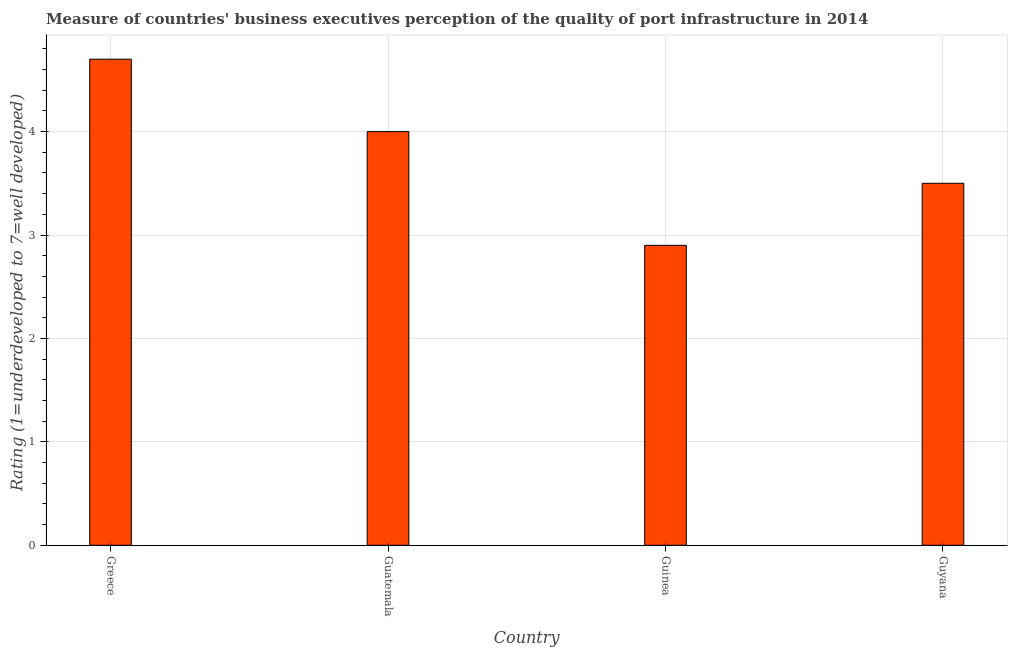Does the graph contain any zero values?
Give a very brief answer. No. What is the title of the graph?
Make the answer very short. Measure of countries' business executives perception of the quality of port infrastructure in 2014. What is the label or title of the Y-axis?
Offer a very short reply. Rating (1=underdeveloped to 7=well developed) . Across all countries, what is the maximum rating measuring quality of port infrastructure?
Offer a terse response. 4.7. In which country was the rating measuring quality of port infrastructure minimum?
Your answer should be compact. Guinea. What is the sum of the rating measuring quality of port infrastructure?
Provide a short and direct response. 15.1. What is the average rating measuring quality of port infrastructure per country?
Give a very brief answer. 3.77. What is the median rating measuring quality of port infrastructure?
Your answer should be very brief. 3.75. What is the ratio of the rating measuring quality of port infrastructure in Guatemala to that in Guyana?
Your answer should be compact. 1.14. Is the difference between the rating measuring quality of port infrastructure in Greece and Guinea greater than the difference between any two countries?
Keep it short and to the point. Yes. What is the difference between the highest and the lowest rating measuring quality of port infrastructure?
Provide a short and direct response. 1.8. How many bars are there?
Give a very brief answer. 4. Are all the bars in the graph horizontal?
Your answer should be compact. No. What is the difference between two consecutive major ticks on the Y-axis?
Keep it short and to the point. 1. Are the values on the major ticks of Y-axis written in scientific E-notation?
Make the answer very short. No. What is the Rating (1=underdeveloped to 7=well developed)  of Greece?
Your answer should be compact. 4.7. What is the Rating (1=underdeveloped to 7=well developed)  in Guatemala?
Offer a terse response. 4. What is the Rating (1=underdeveloped to 7=well developed)  in Guinea?
Provide a succinct answer. 2.9. What is the difference between the Rating (1=underdeveloped to 7=well developed)  in Greece and Guatemala?
Provide a succinct answer. 0.7. What is the difference between the Rating (1=underdeveloped to 7=well developed)  in Greece and Guinea?
Provide a succinct answer. 1.8. What is the difference between the Rating (1=underdeveloped to 7=well developed)  in Guatemala and Guyana?
Give a very brief answer. 0.5. What is the ratio of the Rating (1=underdeveloped to 7=well developed)  in Greece to that in Guatemala?
Keep it short and to the point. 1.18. What is the ratio of the Rating (1=underdeveloped to 7=well developed)  in Greece to that in Guinea?
Ensure brevity in your answer.  1.62. What is the ratio of the Rating (1=underdeveloped to 7=well developed)  in Greece to that in Guyana?
Your answer should be very brief. 1.34. What is the ratio of the Rating (1=underdeveloped to 7=well developed)  in Guatemala to that in Guinea?
Provide a succinct answer. 1.38. What is the ratio of the Rating (1=underdeveloped to 7=well developed)  in Guatemala to that in Guyana?
Your answer should be very brief. 1.14. What is the ratio of the Rating (1=underdeveloped to 7=well developed)  in Guinea to that in Guyana?
Keep it short and to the point. 0.83. 